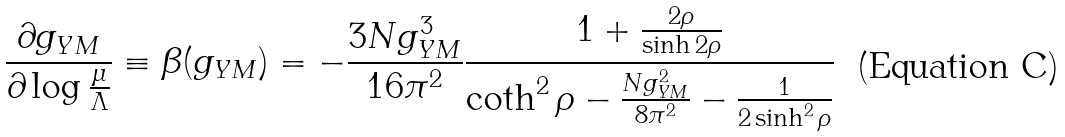Convert formula to latex. <formula><loc_0><loc_0><loc_500><loc_500>\frac { \partial g _ { Y M } } { \partial \log \frac { \mu } { \Lambda } } \equiv \beta ( g _ { Y M } ) = - \frac { 3 N g _ { Y M } ^ { 3 } } { 1 6 \pi ^ { 2 } } \frac { 1 + \frac { 2 \rho } { \sinh 2 \rho } } { \coth ^ { 2 } \rho - \frac { N g ^ { 2 } _ { Y M } } { 8 \pi ^ { 2 } } - \frac { 1 } { 2 \sinh ^ { 2 } \rho } }</formula> 